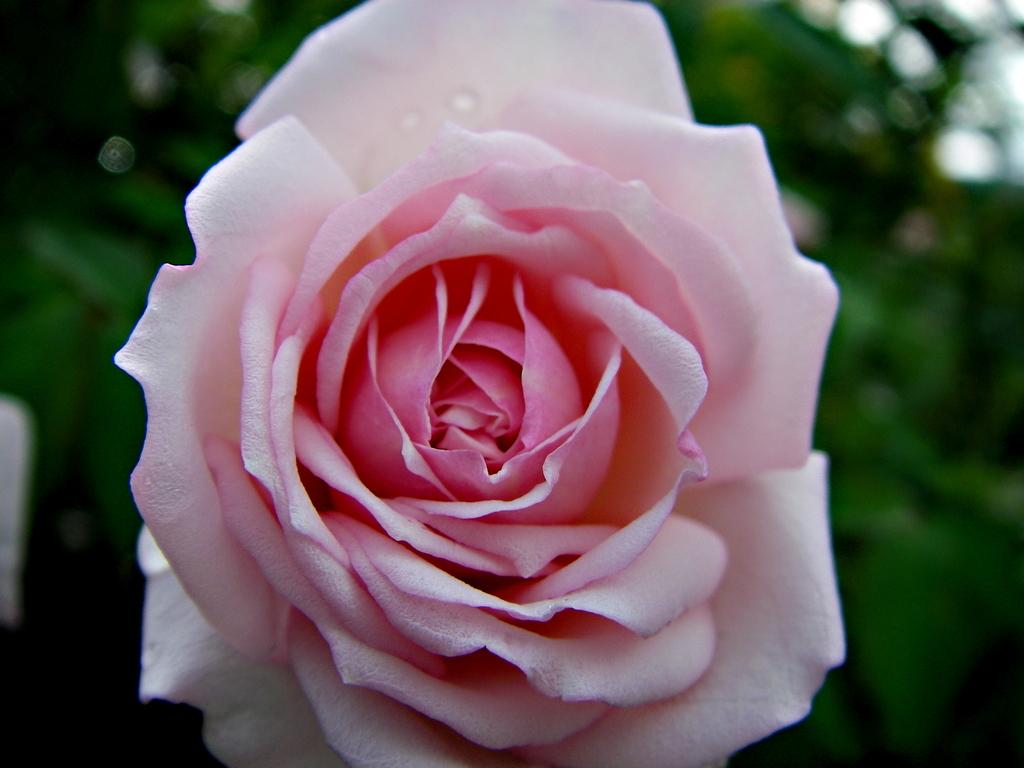What type of flower is in the picture? There is a rose flower in the picture. Can you describe the background of the picture? The background of the picture is blurry. What language is the kitten speaking in the picture? There is no kitten present in the image, and therefore no language can be attributed to it. 